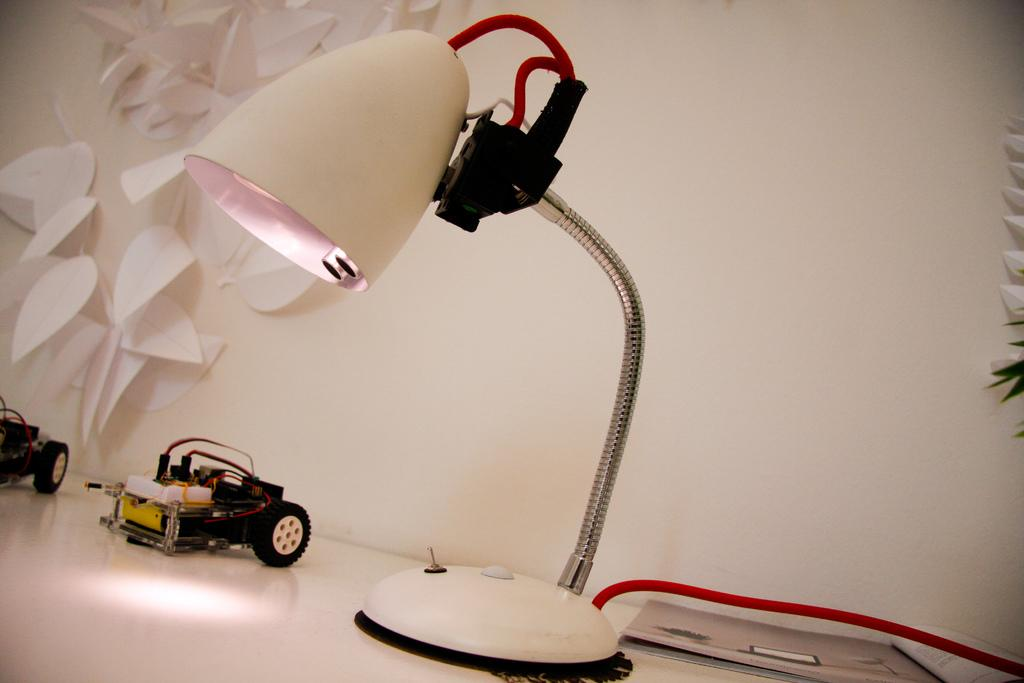What object in the image is typically used for providing light? There is a white table lamp in the image, which is typically used for providing light. Where is the table lamp located in the image? The table lamp is placed on a table in the image. What type of toy can be seen in the image? There is a small car toy in the image. What color is the wall in the background of the image? The background of the image includes a white wall. What decorative elements are present on the white wall? There are paper stickers on the white wall. How many spiders are crawling on the shelf in the image? There is no shelf present in the image, and therefore no spiders can be observed. What type of spot can be seen on the white wall in the image? There is no spot visible on the white wall in the image. 